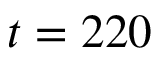<formula> <loc_0><loc_0><loc_500><loc_500>t = 2 2 0</formula> 